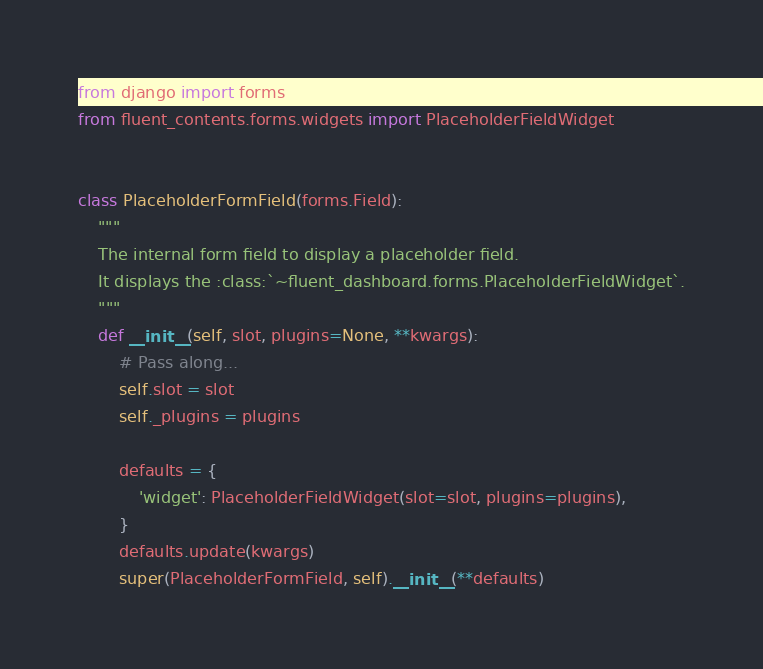<code> <loc_0><loc_0><loc_500><loc_500><_Python_>from django import forms
from fluent_contents.forms.widgets import PlaceholderFieldWidget


class PlaceholderFormField(forms.Field):
    """
    The internal form field to display a placeholder field.
    It displays the :class:`~fluent_dashboard.forms.PlaceholderFieldWidget`.
    """
    def __init__(self, slot, plugins=None, **kwargs):
        # Pass along...
        self.slot = slot
        self._plugins = plugins

        defaults = {
            'widget': PlaceholderFieldWidget(slot=slot, plugins=plugins),
        }
        defaults.update(kwargs)
        super(PlaceholderFormField, self).__init__(**defaults)
</code> 